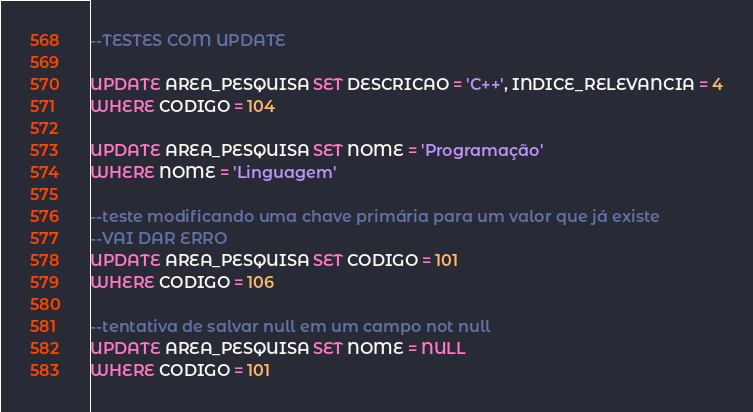Convert code to text. <code><loc_0><loc_0><loc_500><loc_500><_SQL_>--TESTES COM UPDATE

UPDATE AREA_PESQUISA SET DESCRICAO = 'C++', INDICE_RELEVANCIA = 4
WHERE CODIGO = 104

UPDATE AREA_PESQUISA SET NOME = 'Programação' 
WHERE NOME = 'Linguagem'

--teste modificando uma chave primária para um valor que já existe
--VAI DAR ERRO
UPDATE AREA_PESQUISA SET CODIGO = 101
WHERE CODIGO = 106

--tentativa de salvar null em um campo not null
UPDATE AREA_PESQUISA SET NOME = NULL
WHERE CODIGO = 101

</code> 